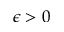<formula> <loc_0><loc_0><loc_500><loc_500>\epsilon > 0</formula> 